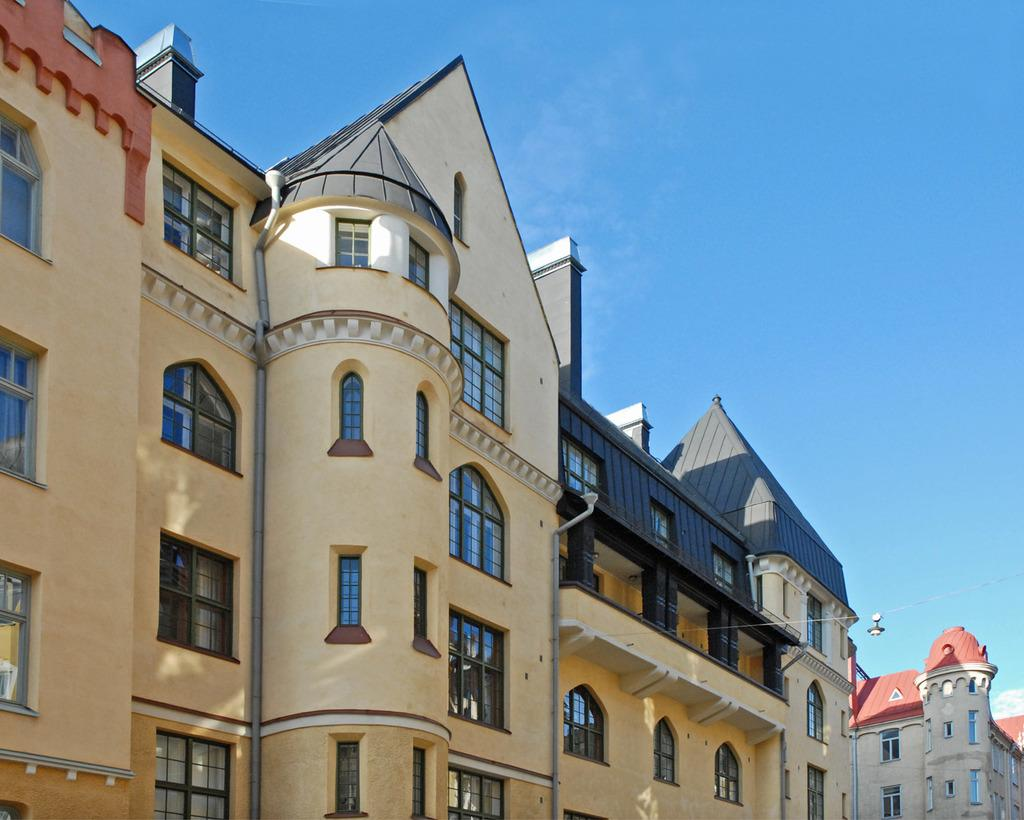What structures are located on the right side of the image? There are buildings on the right side of the image. What feature can be observed on the buildings? The buildings have many windows. What is visible above the buildings in the image? The sky is visible above the buildings. What type of whip can be seen being used in the image? There is no whip present in the image. What industry is depicted in the image? The image does not depict any specific industry; it only shows buildings with many windows and the sky above them. 